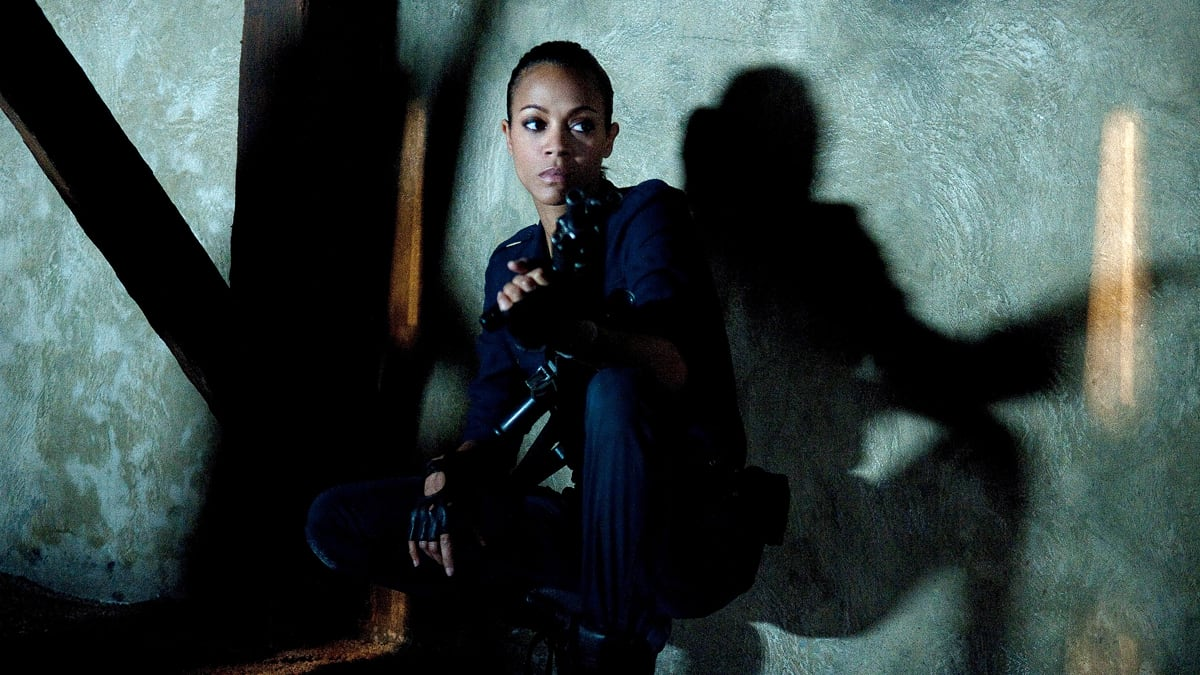What emotions do you think the character is feeling in this moment? The character’s expression and posture convey a mix of determination and alertness, possibly laced with a subtle hint of apprehension, reflecting her readiness to confront imminent danger. 